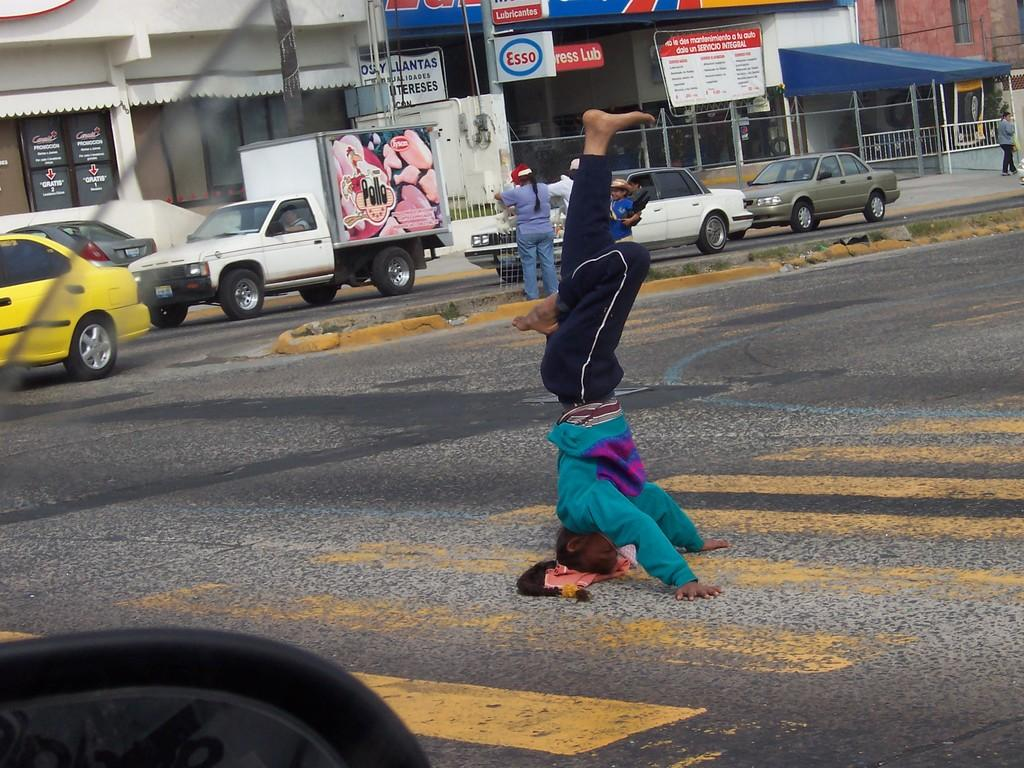What is located at the bottom of the image? There is a road at the bottom of the image. What can be seen in the background of the image? There are vehicles, buildings, and a written text board in the background of the image. What type of song can be heard playing in the background of the image? There is no sound or music present in the image, so it is not possible to determine what song might be heard. 